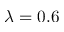Convert formula to latex. <formula><loc_0><loc_0><loc_500><loc_500>\lambda = 0 . 6</formula> 